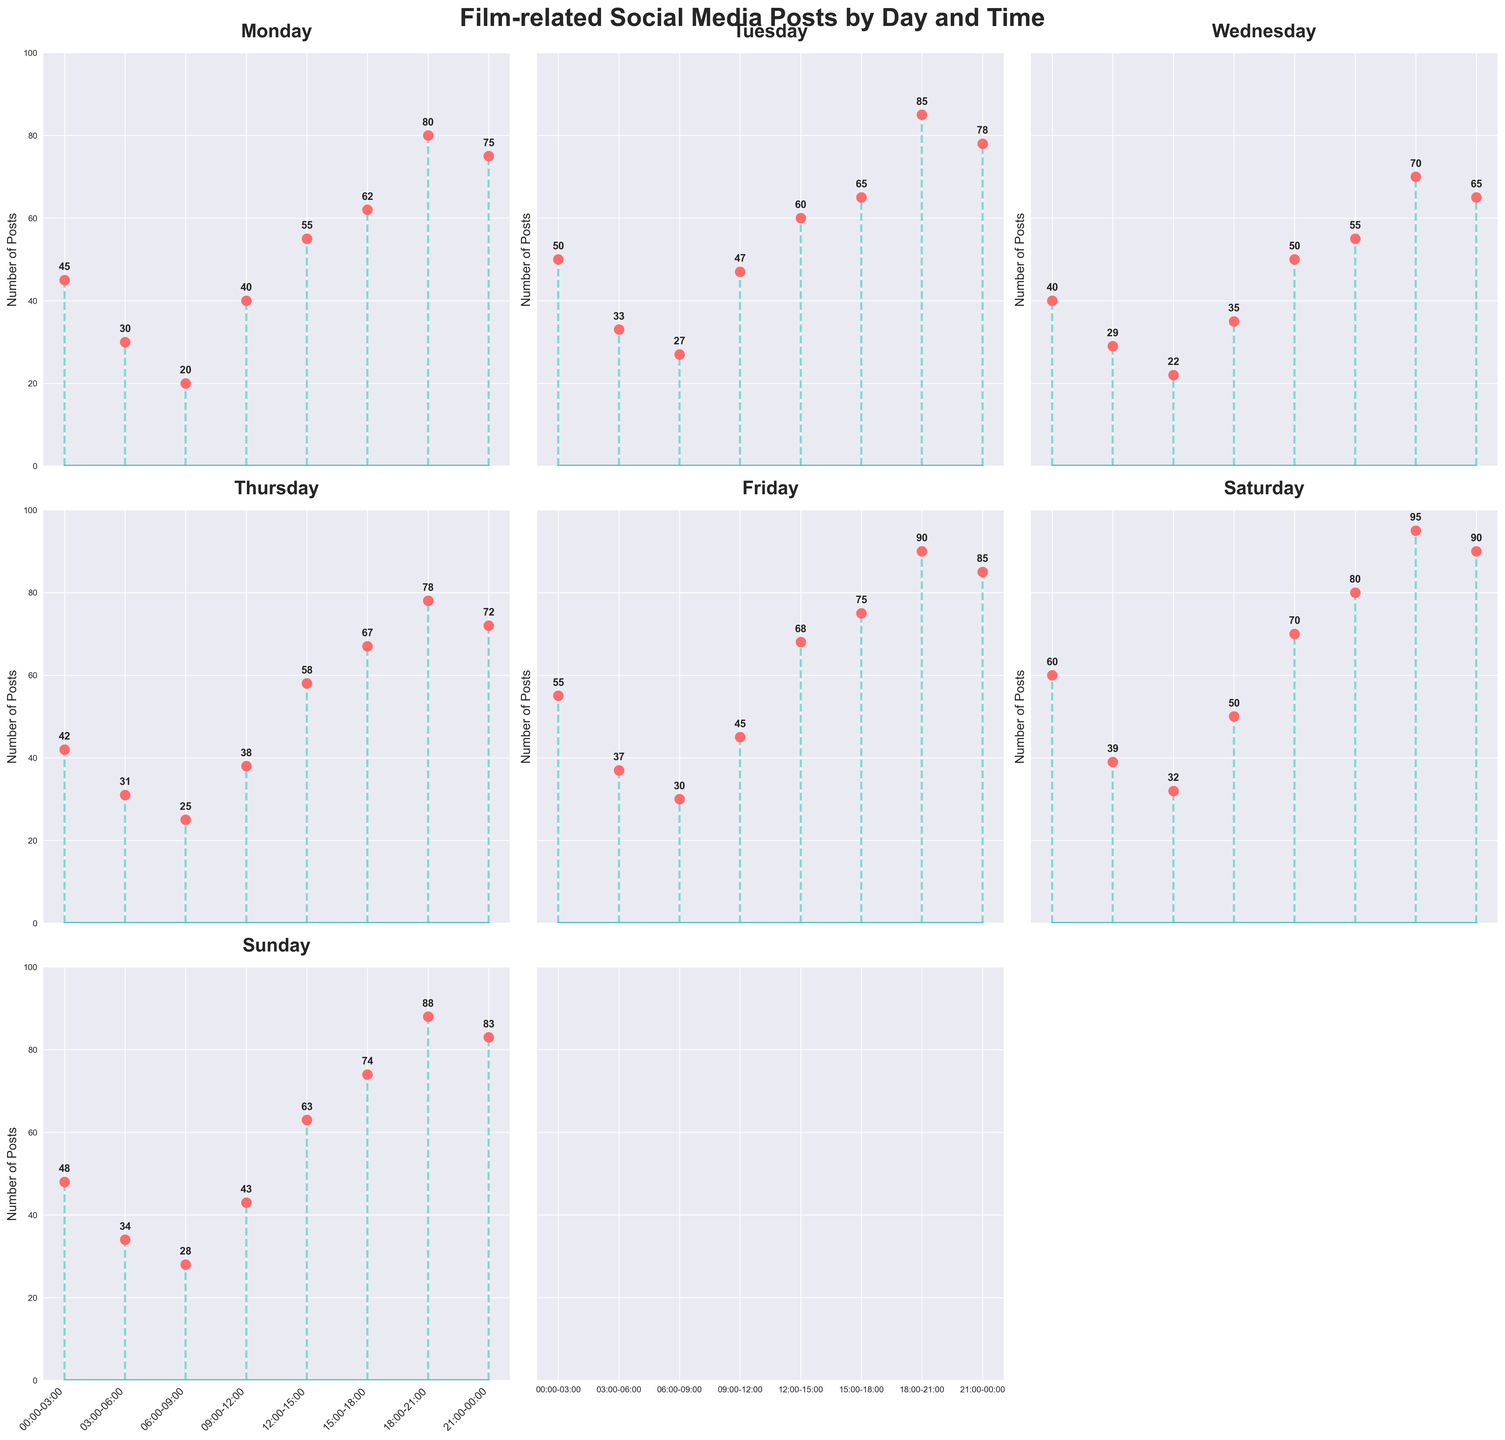What is the title of the figure? The title is located at the top center of the figure in a larger and bold font. It is used to provide a summary of what the figure represents.
Answer: Film-related Social Media Posts by Day and Time How many subplots are there for the posts on weekdays? By glancing at the arrangement of the subplots, one can count the number of subplots corresponding to each day of the week.
Answer: 7 Among all subplots, which time slot tends to have the highest number of posts? Review all the subplots and identify the common time slot that consistently shows the highest values in most subplots. The 18:00-21:00 time slot has the most frequently high post counts in most days.
Answer: 18:00-21:00 What is the post count for Monday at 12:00-15:00? Locate the subplot for Monday, then check the position of the 12:00-15:00 time slot and its corresponding value. It shows a stem reaching up to 55.
Answer: 55 Which day depicts the highest number of posts in the 00:00-03:00 time slot? Compare the post counts for the 00:00-03:00 time slot across all the different days from the subplots. Friday shows the highest count (55).
Answer: Friday During which time slot on Sunday is the post count 88? Concentrate on the subplot for Sunday. Identify the time slot where the stem rises to 88.
Answer: 18:00-21:00 What is the difference in post count between 15:00-18:00 and 03:00-06:00 on Saturday? Calculate the difference by finding the post counts for 15:00-18:00 and 03:00-06:00 on the subplot for Saturday: 80 - 39.
Answer: 41 How does the post count on Tuesday at 21:00-00:00 compare to Monday's at the same time? Examine the two subplots for Monday and Tuesday. Compare their respective post counts at the 21:00-00:00 time slot: Tuesday has 78 and Monday has 75.
Answer: Tuesday is higher What is the average number of posts between Monday and Wednesday for the 09:00-12:00 time slot? To find the average, sum the post counts at 09:00-12:00 for both Monday and Wednesday, and then divide by 2: (40 + 35) / 2 = 37.5.
Answer: 37.5 Which day has the least number of posts at any given time slot? Review all subplots and identify the lowest visible value for any day and time slot. Wednesday at 06:00-09:00 shows the lowest post count of 22.
Answer: Wednesday 